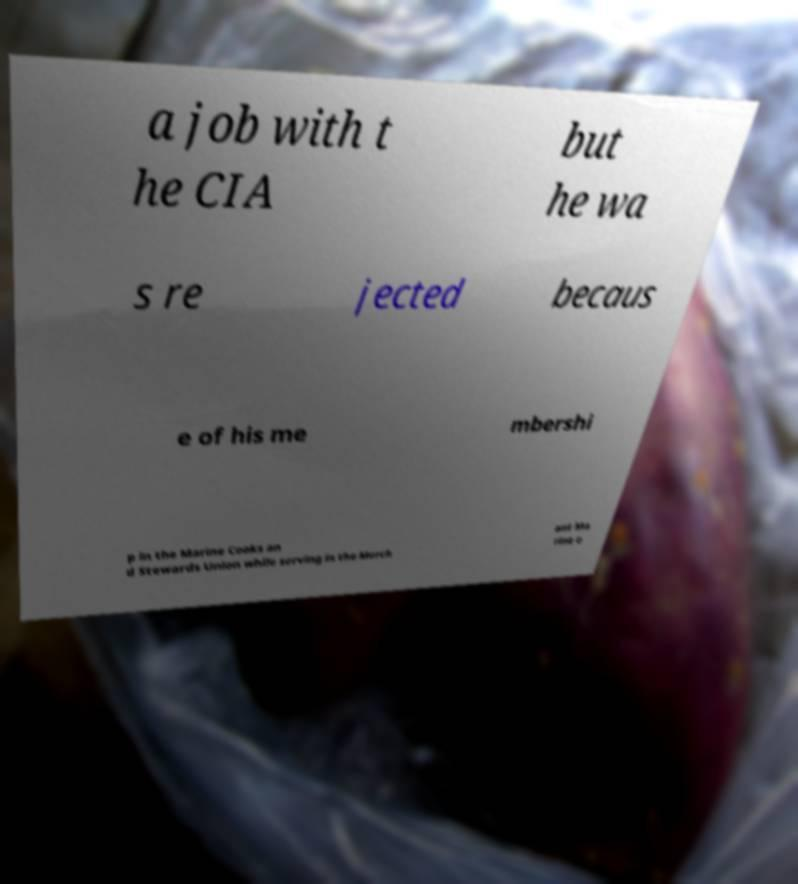For documentation purposes, I need the text within this image transcribed. Could you provide that? a job with t he CIA but he wa s re jected becaus e of his me mbershi p in the Marine Cooks an d Stewards Union while serving in the Merch ant Ma rine e 